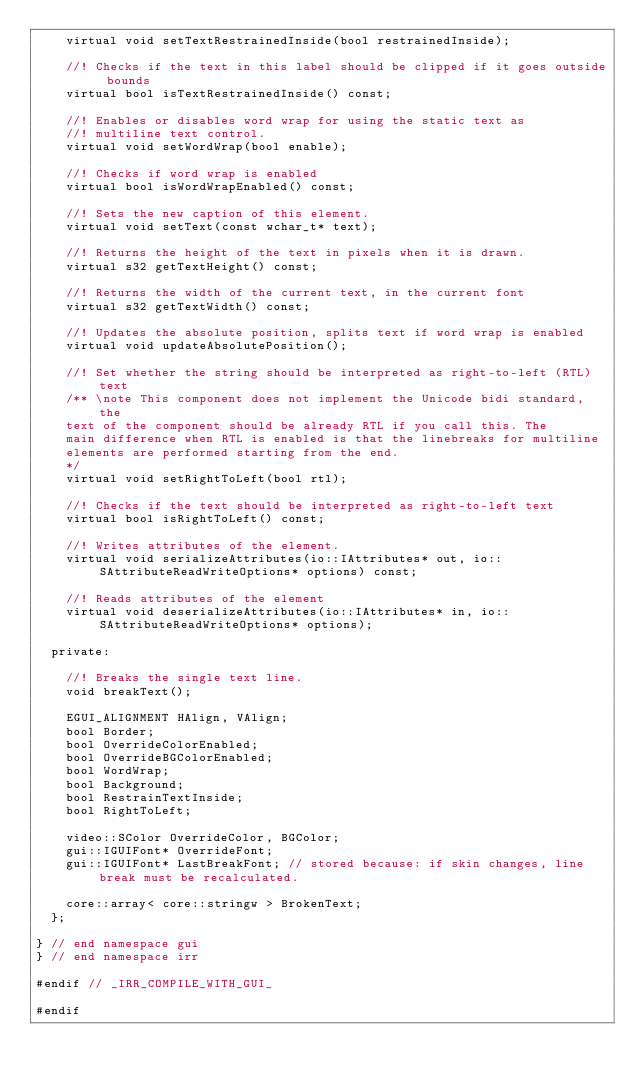<code> <loc_0><loc_0><loc_500><loc_500><_C_>		virtual void setTextRestrainedInside(bool restrainedInside);

		//! Checks if the text in this label should be clipped if it goes outside bounds
		virtual bool isTextRestrainedInside() const;

		//! Enables or disables word wrap for using the static text as
		//! multiline text control.
		virtual void setWordWrap(bool enable);

		//! Checks if word wrap is enabled
		virtual bool isWordWrapEnabled() const;

		//! Sets the new caption of this element.
		virtual void setText(const wchar_t* text);

		//! Returns the height of the text in pixels when it is drawn.
		virtual s32 getTextHeight() const;

		//! Returns the width of the current text, in the current font
		virtual s32 getTextWidth() const;

		//! Updates the absolute position, splits text if word wrap is enabled
		virtual void updateAbsolutePosition();

		//! Set whether the string should be interpreted as right-to-left (RTL) text
		/** \note This component does not implement the Unicode bidi standard, the
		text of the component should be already RTL if you call this. The
		main difference when RTL is enabled is that the linebreaks for multiline
		elements are performed starting from the end.
		*/
		virtual void setRightToLeft(bool rtl);

		//! Checks if the text should be interpreted as right-to-left text
		virtual bool isRightToLeft() const;

		//! Writes attributes of the element.
		virtual void serializeAttributes(io::IAttributes* out, io::SAttributeReadWriteOptions* options) const;

		//! Reads attributes of the element
		virtual void deserializeAttributes(io::IAttributes* in, io::SAttributeReadWriteOptions* options);

	private:

		//! Breaks the single text line.
		void breakText();

		EGUI_ALIGNMENT HAlign, VAlign;
		bool Border;
		bool OverrideColorEnabled;
		bool OverrideBGColorEnabled;
		bool WordWrap;
		bool Background;
		bool RestrainTextInside;
		bool RightToLeft;

		video::SColor OverrideColor, BGColor;
		gui::IGUIFont* OverrideFont;
		gui::IGUIFont* LastBreakFont; // stored because: if skin changes, line break must be recalculated.

		core::array< core::stringw > BrokenText;
	};

} // end namespace gui
} // end namespace irr

#endif // _IRR_COMPILE_WITH_GUI_

#endif

</code> 